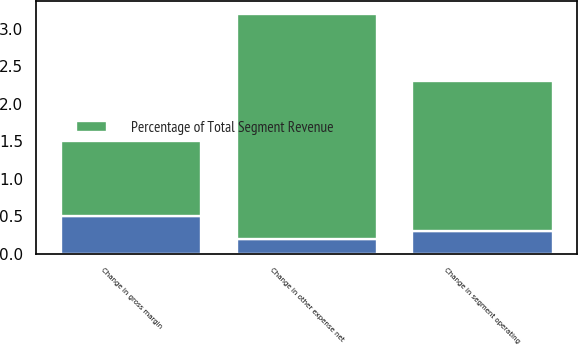<chart> <loc_0><loc_0><loc_500><loc_500><stacked_bar_chart><ecel><fcel>Change in gross margin<fcel>Change in segment operating<fcel>Change in other expense net<nl><fcel>nan<fcel>0.5<fcel>0.3<fcel>0.2<nl><fcel>Percentage of Total Segment Revenue<fcel>1<fcel>2<fcel>3<nl></chart> 